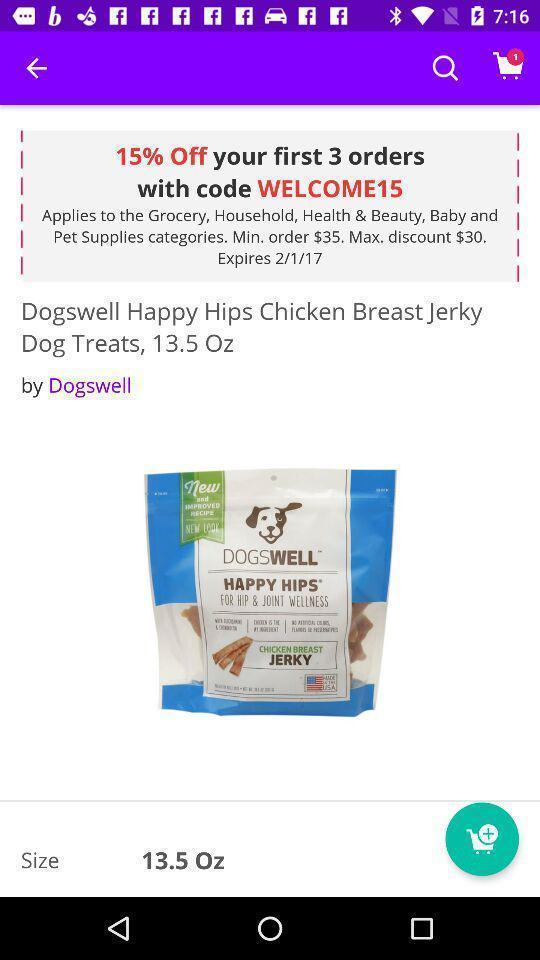What details can you identify in this image? Shopping app displayed an item and offer code. 